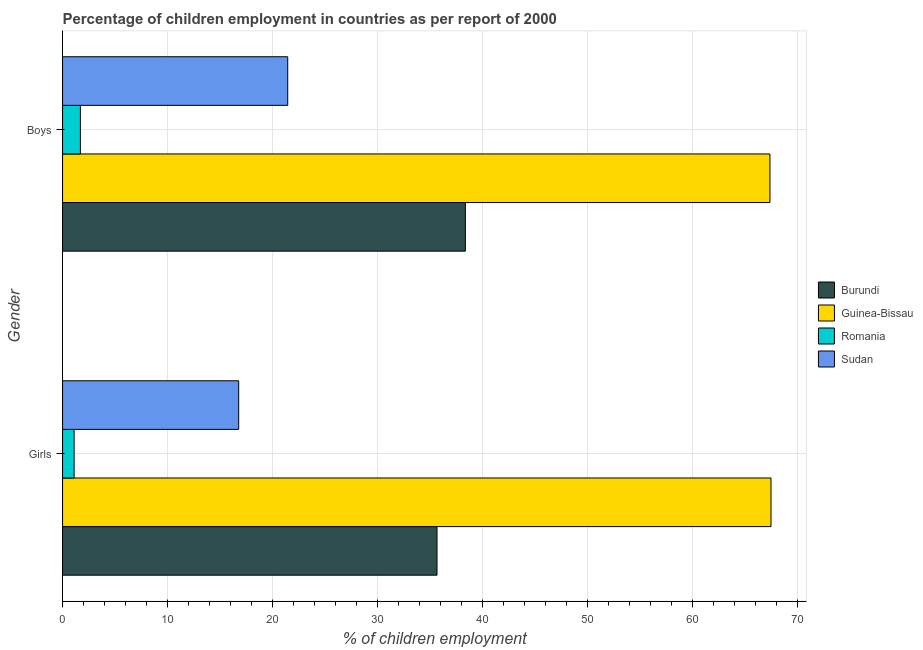How many different coloured bars are there?
Offer a terse response. 4. How many groups of bars are there?
Provide a succinct answer. 2. Are the number of bars per tick equal to the number of legend labels?
Provide a succinct answer. Yes. Are the number of bars on each tick of the Y-axis equal?
Give a very brief answer. Yes. How many bars are there on the 1st tick from the top?
Give a very brief answer. 4. How many bars are there on the 2nd tick from the bottom?
Your response must be concise. 4. What is the label of the 2nd group of bars from the top?
Give a very brief answer. Girls. What is the percentage of employed girls in Guinea-Bissau?
Your response must be concise. 67.5. Across all countries, what is the maximum percentage of employed boys?
Offer a very short reply. 67.4. In which country was the percentage of employed boys maximum?
Offer a terse response. Guinea-Bissau. In which country was the percentage of employed boys minimum?
Provide a succinct answer. Romania. What is the total percentage of employed girls in the graph?
Ensure brevity in your answer.  121.06. What is the difference between the percentage of employed girls in Guinea-Bissau and that in Romania?
Your response must be concise. 66.4. What is the difference between the percentage of employed boys in Sudan and the percentage of employed girls in Guinea-Bissau?
Provide a short and direct response. -46.05. What is the average percentage of employed boys per country?
Offer a very short reply. 32.23. What is the difference between the percentage of employed girls and percentage of employed boys in Burundi?
Offer a very short reply. -2.7. What is the ratio of the percentage of employed girls in Sudan to that in Burundi?
Ensure brevity in your answer.  0.47. In how many countries, is the percentage of employed girls greater than the average percentage of employed girls taken over all countries?
Provide a succinct answer. 2. What does the 1st bar from the top in Boys represents?
Give a very brief answer. Sudan. What does the 1st bar from the bottom in Boys represents?
Your answer should be compact. Burundi. How many bars are there?
Your answer should be compact. 8. What is the difference between two consecutive major ticks on the X-axis?
Ensure brevity in your answer.  10. Where does the legend appear in the graph?
Give a very brief answer. Center right. How many legend labels are there?
Your answer should be very brief. 4. How are the legend labels stacked?
Ensure brevity in your answer.  Vertical. What is the title of the graph?
Your answer should be very brief. Percentage of children employment in countries as per report of 2000. Does "Bangladesh" appear as one of the legend labels in the graph?
Your answer should be compact. No. What is the label or title of the X-axis?
Keep it short and to the point. % of children employment. What is the % of children employment of Burundi in Girls?
Your response must be concise. 35.68. What is the % of children employment in Guinea-Bissau in Girls?
Keep it short and to the point. 67.5. What is the % of children employment of Sudan in Girls?
Give a very brief answer. 16.78. What is the % of children employment in Burundi in Boys?
Offer a very short reply. 38.38. What is the % of children employment in Guinea-Bissau in Boys?
Your answer should be compact. 67.4. What is the % of children employment of Sudan in Boys?
Provide a succinct answer. 21.45. Across all Gender, what is the maximum % of children employment in Burundi?
Your answer should be compact. 38.38. Across all Gender, what is the maximum % of children employment in Guinea-Bissau?
Your response must be concise. 67.5. Across all Gender, what is the maximum % of children employment of Sudan?
Keep it short and to the point. 21.45. Across all Gender, what is the minimum % of children employment in Burundi?
Your answer should be very brief. 35.68. Across all Gender, what is the minimum % of children employment in Guinea-Bissau?
Your answer should be compact. 67.4. Across all Gender, what is the minimum % of children employment in Romania?
Your answer should be very brief. 1.1. Across all Gender, what is the minimum % of children employment in Sudan?
Offer a terse response. 16.78. What is the total % of children employment in Burundi in the graph?
Your answer should be compact. 74.06. What is the total % of children employment of Guinea-Bissau in the graph?
Offer a terse response. 134.9. What is the total % of children employment in Romania in the graph?
Your answer should be very brief. 2.8. What is the total % of children employment in Sudan in the graph?
Provide a succinct answer. 38.23. What is the difference between the % of children employment in Burundi in Girls and that in Boys?
Your answer should be very brief. -2.7. What is the difference between the % of children employment of Sudan in Girls and that in Boys?
Give a very brief answer. -4.67. What is the difference between the % of children employment in Burundi in Girls and the % of children employment in Guinea-Bissau in Boys?
Provide a succinct answer. -31.72. What is the difference between the % of children employment of Burundi in Girls and the % of children employment of Romania in Boys?
Provide a succinct answer. 33.98. What is the difference between the % of children employment in Burundi in Girls and the % of children employment in Sudan in Boys?
Ensure brevity in your answer.  14.22. What is the difference between the % of children employment of Guinea-Bissau in Girls and the % of children employment of Romania in Boys?
Provide a short and direct response. 65.8. What is the difference between the % of children employment in Guinea-Bissau in Girls and the % of children employment in Sudan in Boys?
Your answer should be compact. 46.05. What is the difference between the % of children employment of Romania in Girls and the % of children employment of Sudan in Boys?
Ensure brevity in your answer.  -20.35. What is the average % of children employment of Burundi per Gender?
Keep it short and to the point. 37.03. What is the average % of children employment of Guinea-Bissau per Gender?
Make the answer very short. 67.45. What is the average % of children employment in Sudan per Gender?
Provide a short and direct response. 19.12. What is the difference between the % of children employment of Burundi and % of children employment of Guinea-Bissau in Girls?
Your answer should be compact. -31.82. What is the difference between the % of children employment in Burundi and % of children employment in Romania in Girls?
Your response must be concise. 34.58. What is the difference between the % of children employment of Burundi and % of children employment of Sudan in Girls?
Offer a terse response. 18.9. What is the difference between the % of children employment in Guinea-Bissau and % of children employment in Romania in Girls?
Ensure brevity in your answer.  66.4. What is the difference between the % of children employment of Guinea-Bissau and % of children employment of Sudan in Girls?
Your answer should be very brief. 50.72. What is the difference between the % of children employment in Romania and % of children employment in Sudan in Girls?
Make the answer very short. -15.68. What is the difference between the % of children employment of Burundi and % of children employment of Guinea-Bissau in Boys?
Provide a short and direct response. -29.02. What is the difference between the % of children employment in Burundi and % of children employment in Romania in Boys?
Offer a very short reply. 36.68. What is the difference between the % of children employment of Burundi and % of children employment of Sudan in Boys?
Your answer should be compact. 16.93. What is the difference between the % of children employment in Guinea-Bissau and % of children employment in Romania in Boys?
Keep it short and to the point. 65.7. What is the difference between the % of children employment of Guinea-Bissau and % of children employment of Sudan in Boys?
Provide a short and direct response. 45.95. What is the difference between the % of children employment in Romania and % of children employment in Sudan in Boys?
Offer a terse response. -19.75. What is the ratio of the % of children employment of Burundi in Girls to that in Boys?
Keep it short and to the point. 0.93. What is the ratio of the % of children employment of Guinea-Bissau in Girls to that in Boys?
Your response must be concise. 1. What is the ratio of the % of children employment of Romania in Girls to that in Boys?
Provide a succinct answer. 0.65. What is the ratio of the % of children employment in Sudan in Girls to that in Boys?
Your answer should be very brief. 0.78. What is the difference between the highest and the second highest % of children employment in Burundi?
Give a very brief answer. 2.7. What is the difference between the highest and the second highest % of children employment of Guinea-Bissau?
Your answer should be very brief. 0.1. What is the difference between the highest and the second highest % of children employment in Sudan?
Make the answer very short. 4.67. What is the difference between the highest and the lowest % of children employment in Burundi?
Provide a short and direct response. 2.7. What is the difference between the highest and the lowest % of children employment in Romania?
Ensure brevity in your answer.  0.6. What is the difference between the highest and the lowest % of children employment in Sudan?
Ensure brevity in your answer.  4.67. 